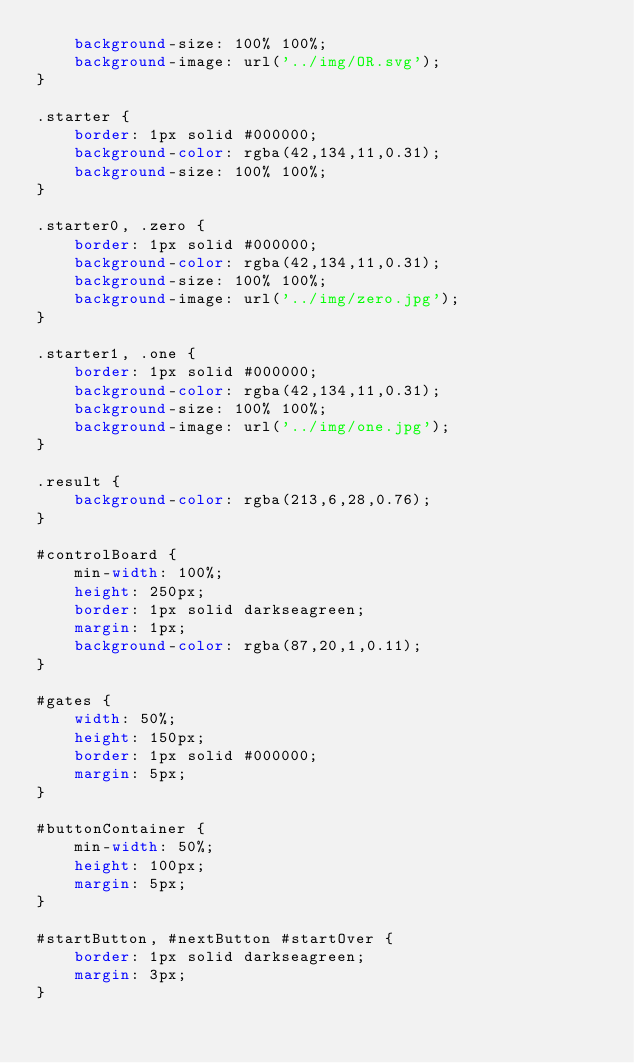Convert code to text. <code><loc_0><loc_0><loc_500><loc_500><_CSS_>    background-size: 100% 100%;
    background-image: url('../img/OR.svg');
}

.starter {
    border: 1px solid #000000;
    background-color: rgba(42,134,11,0.31);
    background-size: 100% 100%;
}

.starter0, .zero {
    border: 1px solid #000000;
    background-color: rgba(42,134,11,0.31);
    background-size: 100% 100%;
    background-image: url('../img/zero.jpg');
}

.starter1, .one {
    border: 1px solid #000000;
    background-color: rgba(42,134,11,0.31);
    background-size: 100% 100%;
    background-image: url('../img/one.jpg');
}

.result {
    background-color: rgba(213,6,28,0.76);
}

#controlBoard {
    min-width: 100%;
    height: 250px;
    border: 1px solid darkseagreen;
    margin: 1px;
    background-color: rgba(87,20,1,0.11);
}

#gates {
    width: 50%;
    height: 150px;
    border: 1px solid #000000;
    margin: 5px;
}

#buttonContainer {
    min-width: 50%;
    height: 100px;
    margin: 5px;
}

#startButton, #nextButton #startOver {
    border: 1px solid darkseagreen;
    margin: 3px;
}
</code> 